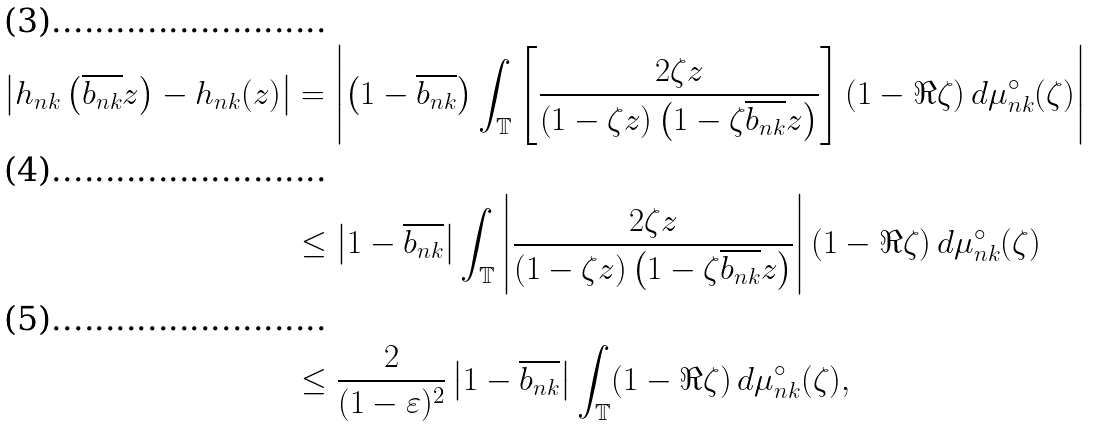<formula> <loc_0><loc_0><loc_500><loc_500>\left | h _ { n k } \left ( \overline { b _ { n k } } z \right ) - h _ { n k } ( z ) \right | & = \left | \left ( 1 - \overline { b _ { n k } } \right ) \int _ { \mathbb { T } } \left [ \frac { 2 \zeta z } { \left ( 1 - \zeta z \right ) \left ( 1 - \zeta \overline { b _ { n k } } z \right ) } \right ] ( 1 - \Re \zeta ) \, d \mu _ { n k } ^ { \circ } ( \zeta ) \right | \\ & \leq \left | 1 - \overline { b _ { n k } } \right | \int _ { \mathbb { T } } \left | \frac { 2 \zeta z } { \left ( 1 - \zeta z \right ) \left ( 1 - \zeta \overline { b _ { n k } } z \right ) } \right | ( 1 - \Re \zeta ) \, d \mu _ { n k } ^ { \circ } ( \zeta ) \\ & \leq \frac { 2 } { ( 1 - \varepsilon ) ^ { 2 } } \left | 1 - \overline { b _ { n k } } \right | \int _ { \mathbb { T } } ( 1 - \Re \zeta ) \, d \mu _ { n k } ^ { \circ } ( \zeta ) ,</formula> 